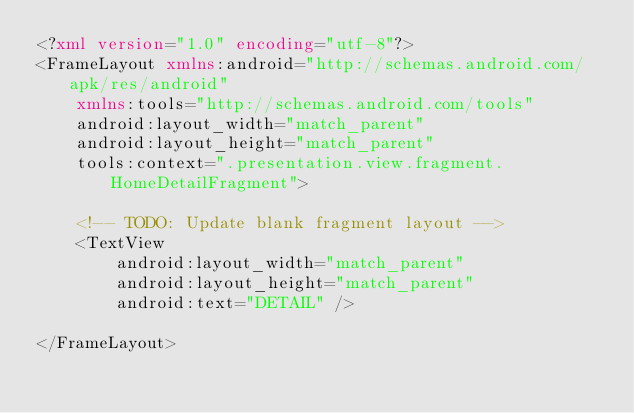Convert code to text. <code><loc_0><loc_0><loc_500><loc_500><_XML_><?xml version="1.0" encoding="utf-8"?>
<FrameLayout xmlns:android="http://schemas.android.com/apk/res/android"
    xmlns:tools="http://schemas.android.com/tools"
    android:layout_width="match_parent"
    android:layout_height="match_parent"
    tools:context=".presentation.view.fragment.HomeDetailFragment">

    <!-- TODO: Update blank fragment layout -->
    <TextView
        android:layout_width="match_parent"
        android:layout_height="match_parent"
        android:text="DETAIL" />

</FrameLayout></code> 